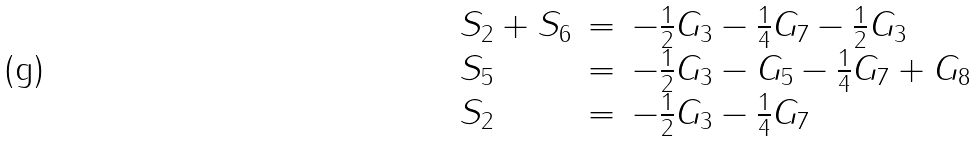<formula> <loc_0><loc_0><loc_500><loc_500>\begin{array} { l l l l } { { S _ { 2 } + S _ { 6 } } } & { = } & { { - { \frac { 1 } { 2 } } G _ { 3 } - { \frac { 1 } { 4 } } G _ { 7 } - { \frac { 1 } { 2 } } G _ { 3 } } } \\ { { S _ { 5 } } } & { = } & { { - { \frac { 1 } { 2 } } G _ { 3 } - G _ { 5 } - { \frac { 1 } { 4 } } G _ { 7 } + G _ { 8 } } } \\ { { S _ { 2 } } } & { = } & { { - { \frac { 1 } { 2 } } G _ { 3 } - { \frac { 1 } { 4 } } G _ { 7 } } } \end{array}</formula> 